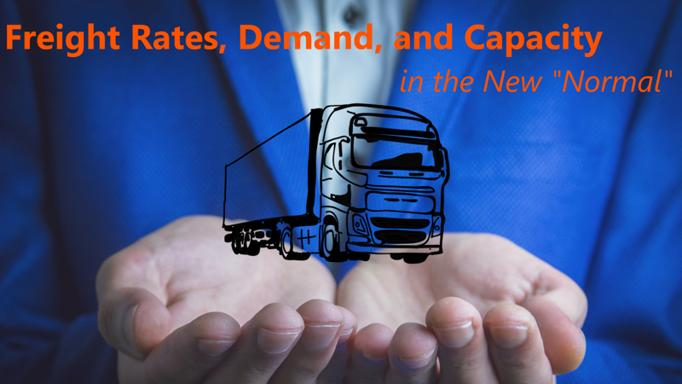Can you explain the role of technology in shaping the trucking industry today? Technology plays a pivotal role in the modern trucking industry by enhancing operational efficiency, improving safety, and reducing costs. Innovations such as automated logistics, real-time tracking systems, and autonomous driving are revolutionizing how freight is managed and transported, enabling more precise and reliable service delivery. 